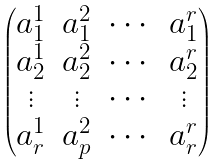Convert formula to latex. <formula><loc_0><loc_0><loc_500><loc_500>\begin{pmatrix} a _ { 1 } ^ { 1 } & a _ { 1 } ^ { 2 } & \cdots & a _ { 1 } ^ { r } \\ a _ { 2 } ^ { 1 } & a _ { 2 } ^ { 2 } & \cdots & a _ { 2 } ^ { r } \\ \vdots & \vdots & \cdots & \vdots \\ a _ { r } ^ { 1 } & a _ { p } ^ { 2 } & \cdots & a _ { r } ^ { r } \\ \end{pmatrix}</formula> 